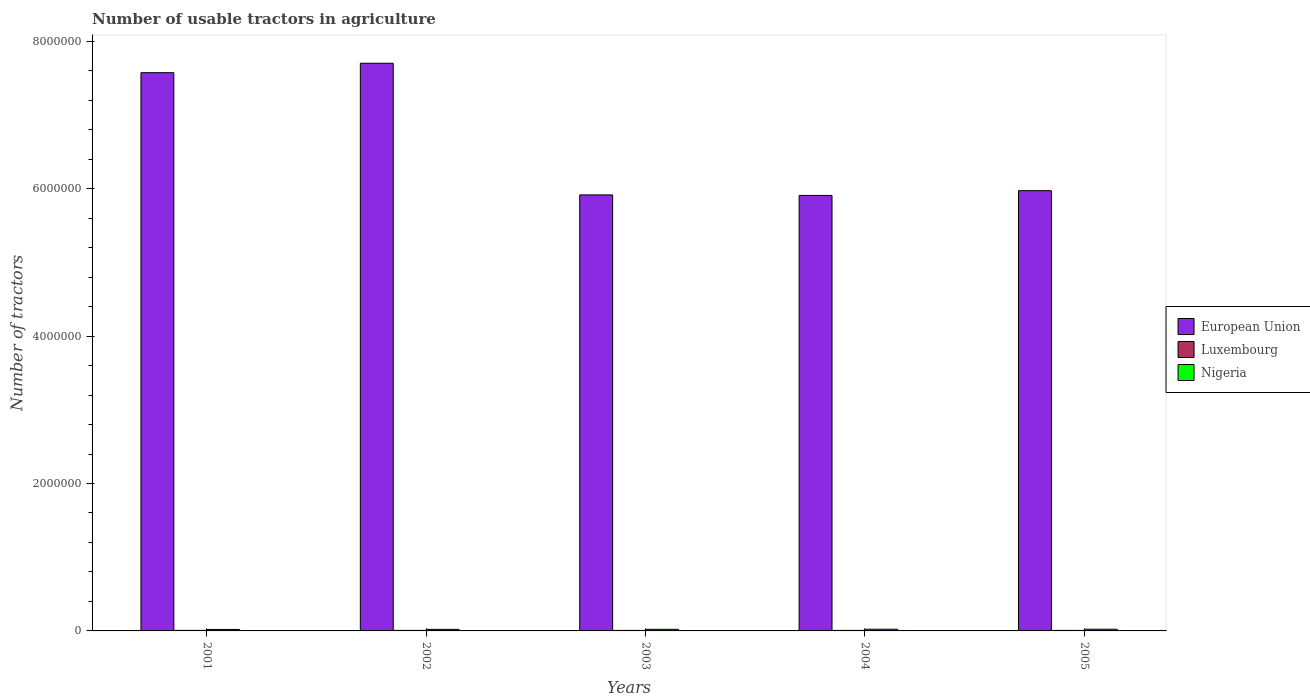How many different coloured bars are there?
Offer a terse response. 3. How many groups of bars are there?
Your answer should be very brief. 5. Are the number of bars on each tick of the X-axis equal?
Your answer should be compact. Yes. How many bars are there on the 1st tick from the left?
Keep it short and to the point. 3. What is the label of the 1st group of bars from the left?
Keep it short and to the point. 2001. In how many cases, is the number of bars for a given year not equal to the number of legend labels?
Ensure brevity in your answer.  0. What is the number of usable tractors in agriculture in European Union in 2004?
Give a very brief answer. 5.91e+06. Across all years, what is the maximum number of usable tractors in agriculture in Luxembourg?
Keep it short and to the point. 7284. Across all years, what is the minimum number of usable tractors in agriculture in European Union?
Keep it short and to the point. 5.91e+06. In which year was the number of usable tractors in agriculture in European Union maximum?
Keep it short and to the point. 2002. In which year was the number of usable tractors in agriculture in European Union minimum?
Offer a very short reply. 2004. What is the total number of usable tractors in agriculture in Luxembourg in the graph?
Provide a succinct answer. 3.49e+04. What is the difference between the number of usable tractors in agriculture in European Union in 2002 and that in 2004?
Make the answer very short. 1.79e+06. What is the difference between the number of usable tractors in agriculture in Nigeria in 2002 and the number of usable tractors in agriculture in European Union in 2004?
Your response must be concise. -5.89e+06. What is the average number of usable tractors in agriculture in European Union per year?
Provide a short and direct response. 6.61e+06. In the year 2003, what is the difference between the number of usable tractors in agriculture in Luxembourg and number of usable tractors in agriculture in Nigeria?
Give a very brief answer. -1.51e+04. What is the ratio of the number of usable tractors in agriculture in European Union in 2002 to that in 2003?
Give a very brief answer. 1.3. Is the number of usable tractors in agriculture in Luxembourg in 2004 less than that in 2005?
Offer a very short reply. Yes. Is the difference between the number of usable tractors in agriculture in Luxembourg in 2002 and 2005 greater than the difference between the number of usable tractors in agriculture in Nigeria in 2002 and 2005?
Make the answer very short. Yes. What is the difference between the highest and the second highest number of usable tractors in agriculture in Nigeria?
Offer a terse response. 0. What is the difference between the highest and the lowest number of usable tractors in agriculture in European Union?
Offer a very short reply. 1.79e+06. What does the 2nd bar from the left in 2004 represents?
Offer a very short reply. Luxembourg. What does the 2nd bar from the right in 2001 represents?
Your answer should be compact. Luxembourg. Is it the case that in every year, the sum of the number of usable tractors in agriculture in European Union and number of usable tractors in agriculture in Luxembourg is greater than the number of usable tractors in agriculture in Nigeria?
Make the answer very short. Yes. How many years are there in the graph?
Provide a succinct answer. 5. What is the title of the graph?
Offer a very short reply. Number of usable tractors in agriculture. What is the label or title of the X-axis?
Your response must be concise. Years. What is the label or title of the Y-axis?
Make the answer very short. Number of tractors. What is the Number of tractors of European Union in 2001?
Offer a very short reply. 7.57e+06. What is the Number of tractors in Luxembourg in 2001?
Keep it short and to the point. 7284. What is the Number of tractors of Nigeria in 2001?
Provide a short and direct response. 2.00e+04. What is the Number of tractors of European Union in 2002?
Provide a short and direct response. 7.70e+06. What is the Number of tractors of Luxembourg in 2002?
Your answer should be very brief. 7042. What is the Number of tractors of Nigeria in 2002?
Ensure brevity in your answer.  2.10e+04. What is the Number of tractors in European Union in 2003?
Ensure brevity in your answer.  5.92e+06. What is the Number of tractors in Luxembourg in 2003?
Make the answer very short. 6926. What is the Number of tractors of Nigeria in 2003?
Give a very brief answer. 2.20e+04. What is the Number of tractors of European Union in 2004?
Make the answer very short. 5.91e+06. What is the Number of tractors in Luxembourg in 2004?
Provide a short and direct response. 6787. What is the Number of tractors of Nigeria in 2004?
Your answer should be very brief. 2.30e+04. What is the Number of tractors of European Union in 2005?
Make the answer very short. 5.97e+06. What is the Number of tractors in Luxembourg in 2005?
Your answer should be very brief. 6898. What is the Number of tractors in Nigeria in 2005?
Your response must be concise. 2.30e+04. Across all years, what is the maximum Number of tractors in European Union?
Your answer should be compact. 7.70e+06. Across all years, what is the maximum Number of tractors in Luxembourg?
Offer a very short reply. 7284. Across all years, what is the maximum Number of tractors in Nigeria?
Provide a short and direct response. 2.30e+04. Across all years, what is the minimum Number of tractors in European Union?
Your answer should be very brief. 5.91e+06. Across all years, what is the minimum Number of tractors of Luxembourg?
Offer a very short reply. 6787. Across all years, what is the minimum Number of tractors in Nigeria?
Your answer should be compact. 2.00e+04. What is the total Number of tractors of European Union in the graph?
Provide a succinct answer. 3.31e+07. What is the total Number of tractors of Luxembourg in the graph?
Make the answer very short. 3.49e+04. What is the total Number of tractors of Nigeria in the graph?
Offer a terse response. 1.09e+05. What is the difference between the Number of tractors in European Union in 2001 and that in 2002?
Offer a terse response. -1.28e+05. What is the difference between the Number of tractors in Luxembourg in 2001 and that in 2002?
Give a very brief answer. 242. What is the difference between the Number of tractors of Nigeria in 2001 and that in 2002?
Give a very brief answer. -994. What is the difference between the Number of tractors in European Union in 2001 and that in 2003?
Ensure brevity in your answer.  1.66e+06. What is the difference between the Number of tractors of Luxembourg in 2001 and that in 2003?
Offer a terse response. 358. What is the difference between the Number of tractors in Nigeria in 2001 and that in 2003?
Your response must be concise. -1994. What is the difference between the Number of tractors of European Union in 2001 and that in 2004?
Your answer should be compact. 1.67e+06. What is the difference between the Number of tractors in Luxembourg in 2001 and that in 2004?
Provide a succinct answer. 497. What is the difference between the Number of tractors in Nigeria in 2001 and that in 2004?
Your answer should be compact. -2994. What is the difference between the Number of tractors in European Union in 2001 and that in 2005?
Provide a short and direct response. 1.60e+06. What is the difference between the Number of tractors in Luxembourg in 2001 and that in 2005?
Your response must be concise. 386. What is the difference between the Number of tractors in Nigeria in 2001 and that in 2005?
Ensure brevity in your answer.  -2994. What is the difference between the Number of tractors of European Union in 2002 and that in 2003?
Give a very brief answer. 1.79e+06. What is the difference between the Number of tractors in Luxembourg in 2002 and that in 2003?
Offer a very short reply. 116. What is the difference between the Number of tractors in Nigeria in 2002 and that in 2003?
Your answer should be compact. -1000. What is the difference between the Number of tractors of European Union in 2002 and that in 2004?
Make the answer very short. 1.79e+06. What is the difference between the Number of tractors in Luxembourg in 2002 and that in 2004?
Your answer should be compact. 255. What is the difference between the Number of tractors of Nigeria in 2002 and that in 2004?
Your answer should be compact. -2000. What is the difference between the Number of tractors in European Union in 2002 and that in 2005?
Ensure brevity in your answer.  1.73e+06. What is the difference between the Number of tractors in Luxembourg in 2002 and that in 2005?
Keep it short and to the point. 144. What is the difference between the Number of tractors of Nigeria in 2002 and that in 2005?
Make the answer very short. -2000. What is the difference between the Number of tractors in European Union in 2003 and that in 2004?
Provide a succinct answer. 7000. What is the difference between the Number of tractors in Luxembourg in 2003 and that in 2004?
Your response must be concise. 139. What is the difference between the Number of tractors of Nigeria in 2003 and that in 2004?
Make the answer very short. -1000. What is the difference between the Number of tractors of European Union in 2003 and that in 2005?
Ensure brevity in your answer.  -5.73e+04. What is the difference between the Number of tractors of Luxembourg in 2003 and that in 2005?
Make the answer very short. 28. What is the difference between the Number of tractors of Nigeria in 2003 and that in 2005?
Provide a short and direct response. -1000. What is the difference between the Number of tractors in European Union in 2004 and that in 2005?
Provide a succinct answer. -6.43e+04. What is the difference between the Number of tractors of Luxembourg in 2004 and that in 2005?
Keep it short and to the point. -111. What is the difference between the Number of tractors of Nigeria in 2004 and that in 2005?
Offer a very short reply. 0. What is the difference between the Number of tractors of European Union in 2001 and the Number of tractors of Luxembourg in 2002?
Provide a succinct answer. 7.57e+06. What is the difference between the Number of tractors in European Union in 2001 and the Number of tractors in Nigeria in 2002?
Provide a succinct answer. 7.55e+06. What is the difference between the Number of tractors of Luxembourg in 2001 and the Number of tractors of Nigeria in 2002?
Provide a short and direct response. -1.37e+04. What is the difference between the Number of tractors of European Union in 2001 and the Number of tractors of Luxembourg in 2003?
Provide a succinct answer. 7.57e+06. What is the difference between the Number of tractors of European Union in 2001 and the Number of tractors of Nigeria in 2003?
Offer a very short reply. 7.55e+06. What is the difference between the Number of tractors in Luxembourg in 2001 and the Number of tractors in Nigeria in 2003?
Offer a terse response. -1.47e+04. What is the difference between the Number of tractors in European Union in 2001 and the Number of tractors in Luxembourg in 2004?
Your answer should be very brief. 7.57e+06. What is the difference between the Number of tractors of European Union in 2001 and the Number of tractors of Nigeria in 2004?
Offer a very short reply. 7.55e+06. What is the difference between the Number of tractors in Luxembourg in 2001 and the Number of tractors in Nigeria in 2004?
Provide a succinct answer. -1.57e+04. What is the difference between the Number of tractors in European Union in 2001 and the Number of tractors in Luxembourg in 2005?
Your response must be concise. 7.57e+06. What is the difference between the Number of tractors of European Union in 2001 and the Number of tractors of Nigeria in 2005?
Provide a short and direct response. 7.55e+06. What is the difference between the Number of tractors in Luxembourg in 2001 and the Number of tractors in Nigeria in 2005?
Give a very brief answer. -1.57e+04. What is the difference between the Number of tractors in European Union in 2002 and the Number of tractors in Luxembourg in 2003?
Make the answer very short. 7.69e+06. What is the difference between the Number of tractors of European Union in 2002 and the Number of tractors of Nigeria in 2003?
Give a very brief answer. 7.68e+06. What is the difference between the Number of tractors in Luxembourg in 2002 and the Number of tractors in Nigeria in 2003?
Your answer should be compact. -1.50e+04. What is the difference between the Number of tractors in European Union in 2002 and the Number of tractors in Luxembourg in 2004?
Your response must be concise. 7.69e+06. What is the difference between the Number of tractors of European Union in 2002 and the Number of tractors of Nigeria in 2004?
Offer a terse response. 7.68e+06. What is the difference between the Number of tractors of Luxembourg in 2002 and the Number of tractors of Nigeria in 2004?
Your response must be concise. -1.60e+04. What is the difference between the Number of tractors in European Union in 2002 and the Number of tractors in Luxembourg in 2005?
Offer a very short reply. 7.69e+06. What is the difference between the Number of tractors of European Union in 2002 and the Number of tractors of Nigeria in 2005?
Your response must be concise. 7.68e+06. What is the difference between the Number of tractors of Luxembourg in 2002 and the Number of tractors of Nigeria in 2005?
Ensure brevity in your answer.  -1.60e+04. What is the difference between the Number of tractors in European Union in 2003 and the Number of tractors in Luxembourg in 2004?
Your answer should be very brief. 5.91e+06. What is the difference between the Number of tractors in European Union in 2003 and the Number of tractors in Nigeria in 2004?
Give a very brief answer. 5.89e+06. What is the difference between the Number of tractors of Luxembourg in 2003 and the Number of tractors of Nigeria in 2004?
Your answer should be very brief. -1.61e+04. What is the difference between the Number of tractors of European Union in 2003 and the Number of tractors of Luxembourg in 2005?
Your answer should be compact. 5.91e+06. What is the difference between the Number of tractors in European Union in 2003 and the Number of tractors in Nigeria in 2005?
Make the answer very short. 5.89e+06. What is the difference between the Number of tractors of Luxembourg in 2003 and the Number of tractors of Nigeria in 2005?
Make the answer very short. -1.61e+04. What is the difference between the Number of tractors in European Union in 2004 and the Number of tractors in Luxembourg in 2005?
Ensure brevity in your answer.  5.90e+06. What is the difference between the Number of tractors of European Union in 2004 and the Number of tractors of Nigeria in 2005?
Your answer should be compact. 5.89e+06. What is the difference between the Number of tractors of Luxembourg in 2004 and the Number of tractors of Nigeria in 2005?
Give a very brief answer. -1.62e+04. What is the average Number of tractors of European Union per year?
Offer a very short reply. 6.61e+06. What is the average Number of tractors of Luxembourg per year?
Your answer should be compact. 6987.4. What is the average Number of tractors in Nigeria per year?
Ensure brevity in your answer.  2.18e+04. In the year 2001, what is the difference between the Number of tractors in European Union and Number of tractors in Luxembourg?
Offer a terse response. 7.57e+06. In the year 2001, what is the difference between the Number of tractors in European Union and Number of tractors in Nigeria?
Provide a short and direct response. 7.55e+06. In the year 2001, what is the difference between the Number of tractors of Luxembourg and Number of tractors of Nigeria?
Keep it short and to the point. -1.27e+04. In the year 2002, what is the difference between the Number of tractors of European Union and Number of tractors of Luxembourg?
Provide a succinct answer. 7.69e+06. In the year 2002, what is the difference between the Number of tractors in European Union and Number of tractors in Nigeria?
Give a very brief answer. 7.68e+06. In the year 2002, what is the difference between the Number of tractors in Luxembourg and Number of tractors in Nigeria?
Give a very brief answer. -1.40e+04. In the year 2003, what is the difference between the Number of tractors in European Union and Number of tractors in Luxembourg?
Make the answer very short. 5.91e+06. In the year 2003, what is the difference between the Number of tractors of European Union and Number of tractors of Nigeria?
Give a very brief answer. 5.89e+06. In the year 2003, what is the difference between the Number of tractors of Luxembourg and Number of tractors of Nigeria?
Your answer should be very brief. -1.51e+04. In the year 2004, what is the difference between the Number of tractors in European Union and Number of tractors in Luxembourg?
Give a very brief answer. 5.90e+06. In the year 2004, what is the difference between the Number of tractors of European Union and Number of tractors of Nigeria?
Provide a short and direct response. 5.89e+06. In the year 2004, what is the difference between the Number of tractors of Luxembourg and Number of tractors of Nigeria?
Offer a terse response. -1.62e+04. In the year 2005, what is the difference between the Number of tractors of European Union and Number of tractors of Luxembourg?
Give a very brief answer. 5.97e+06. In the year 2005, what is the difference between the Number of tractors in European Union and Number of tractors in Nigeria?
Make the answer very short. 5.95e+06. In the year 2005, what is the difference between the Number of tractors of Luxembourg and Number of tractors of Nigeria?
Keep it short and to the point. -1.61e+04. What is the ratio of the Number of tractors in European Union in 2001 to that in 2002?
Give a very brief answer. 0.98. What is the ratio of the Number of tractors of Luxembourg in 2001 to that in 2002?
Offer a very short reply. 1.03. What is the ratio of the Number of tractors in Nigeria in 2001 to that in 2002?
Your answer should be compact. 0.95. What is the ratio of the Number of tractors of European Union in 2001 to that in 2003?
Offer a terse response. 1.28. What is the ratio of the Number of tractors of Luxembourg in 2001 to that in 2003?
Ensure brevity in your answer.  1.05. What is the ratio of the Number of tractors of Nigeria in 2001 to that in 2003?
Ensure brevity in your answer.  0.91. What is the ratio of the Number of tractors in European Union in 2001 to that in 2004?
Offer a terse response. 1.28. What is the ratio of the Number of tractors in Luxembourg in 2001 to that in 2004?
Provide a succinct answer. 1.07. What is the ratio of the Number of tractors of Nigeria in 2001 to that in 2004?
Your answer should be very brief. 0.87. What is the ratio of the Number of tractors in European Union in 2001 to that in 2005?
Your answer should be compact. 1.27. What is the ratio of the Number of tractors of Luxembourg in 2001 to that in 2005?
Offer a terse response. 1.06. What is the ratio of the Number of tractors of Nigeria in 2001 to that in 2005?
Ensure brevity in your answer.  0.87. What is the ratio of the Number of tractors in European Union in 2002 to that in 2003?
Your answer should be very brief. 1.3. What is the ratio of the Number of tractors of Luxembourg in 2002 to that in 2003?
Keep it short and to the point. 1.02. What is the ratio of the Number of tractors in Nigeria in 2002 to that in 2003?
Keep it short and to the point. 0.95. What is the ratio of the Number of tractors in European Union in 2002 to that in 2004?
Your response must be concise. 1.3. What is the ratio of the Number of tractors in Luxembourg in 2002 to that in 2004?
Give a very brief answer. 1.04. What is the ratio of the Number of tractors of Nigeria in 2002 to that in 2004?
Your answer should be compact. 0.91. What is the ratio of the Number of tractors of European Union in 2002 to that in 2005?
Ensure brevity in your answer.  1.29. What is the ratio of the Number of tractors of Luxembourg in 2002 to that in 2005?
Give a very brief answer. 1.02. What is the ratio of the Number of tractors in Nigeria in 2002 to that in 2005?
Offer a terse response. 0.91. What is the ratio of the Number of tractors of Luxembourg in 2003 to that in 2004?
Give a very brief answer. 1.02. What is the ratio of the Number of tractors in Nigeria in 2003 to that in 2004?
Keep it short and to the point. 0.96. What is the ratio of the Number of tractors in Nigeria in 2003 to that in 2005?
Your answer should be compact. 0.96. What is the ratio of the Number of tractors of Luxembourg in 2004 to that in 2005?
Offer a very short reply. 0.98. What is the difference between the highest and the second highest Number of tractors of European Union?
Offer a very short reply. 1.28e+05. What is the difference between the highest and the second highest Number of tractors in Luxembourg?
Your response must be concise. 242. What is the difference between the highest and the second highest Number of tractors of Nigeria?
Offer a very short reply. 0. What is the difference between the highest and the lowest Number of tractors in European Union?
Provide a short and direct response. 1.79e+06. What is the difference between the highest and the lowest Number of tractors of Luxembourg?
Ensure brevity in your answer.  497. What is the difference between the highest and the lowest Number of tractors of Nigeria?
Offer a terse response. 2994. 